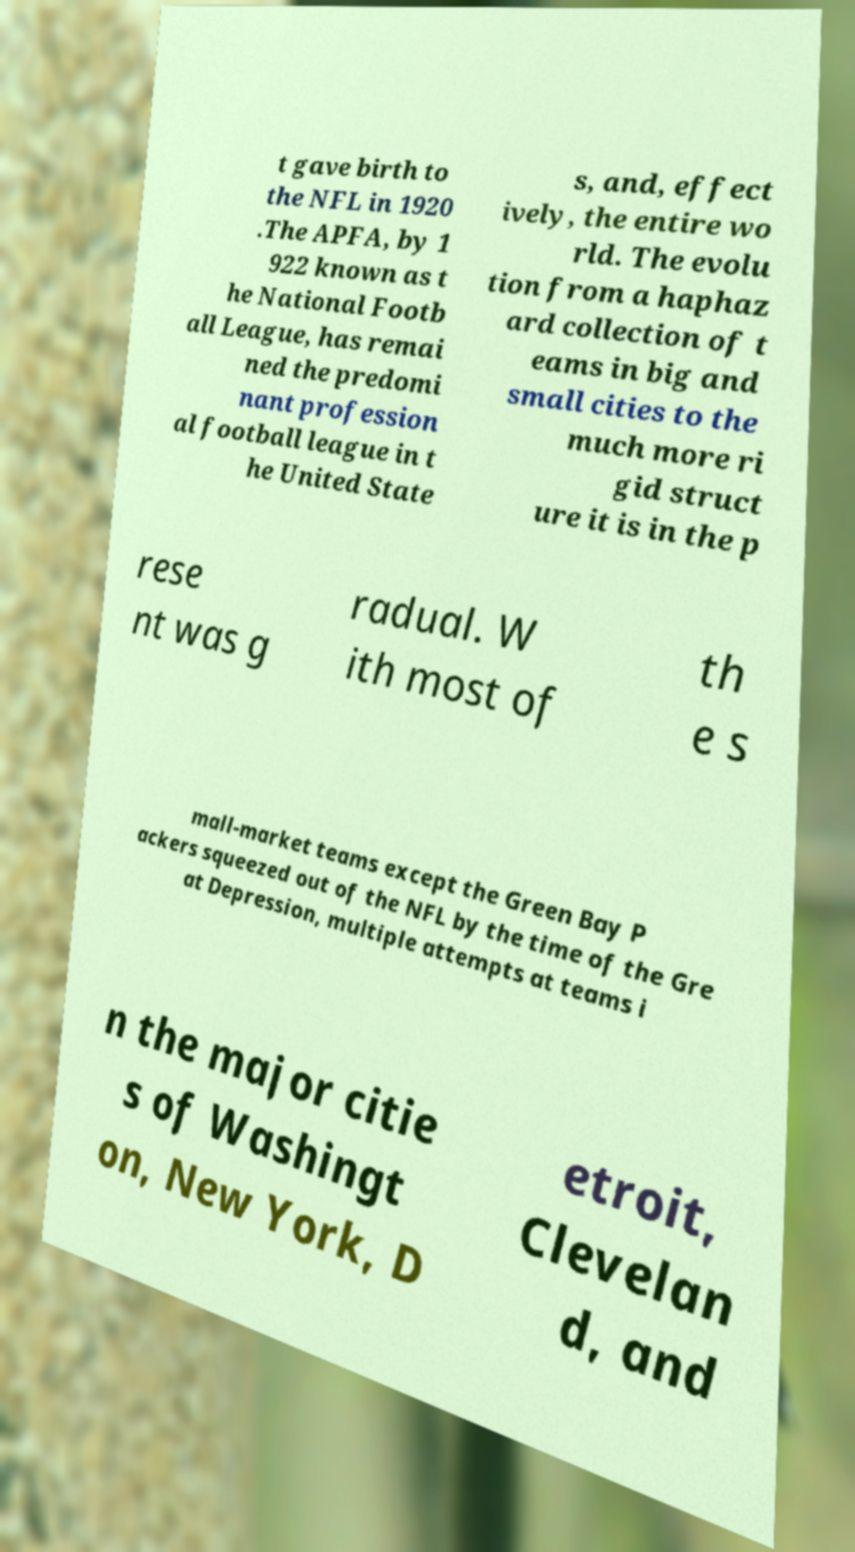Could you extract and type out the text from this image? t gave birth to the NFL in 1920 .The APFA, by 1 922 known as t he National Footb all League, has remai ned the predomi nant profession al football league in t he United State s, and, effect ively, the entire wo rld. The evolu tion from a haphaz ard collection of t eams in big and small cities to the much more ri gid struct ure it is in the p rese nt was g radual. W ith most of th e s mall-market teams except the Green Bay P ackers squeezed out of the NFL by the time of the Gre at Depression, multiple attempts at teams i n the major citie s of Washingt on, New York, D etroit, Clevelan d, and 